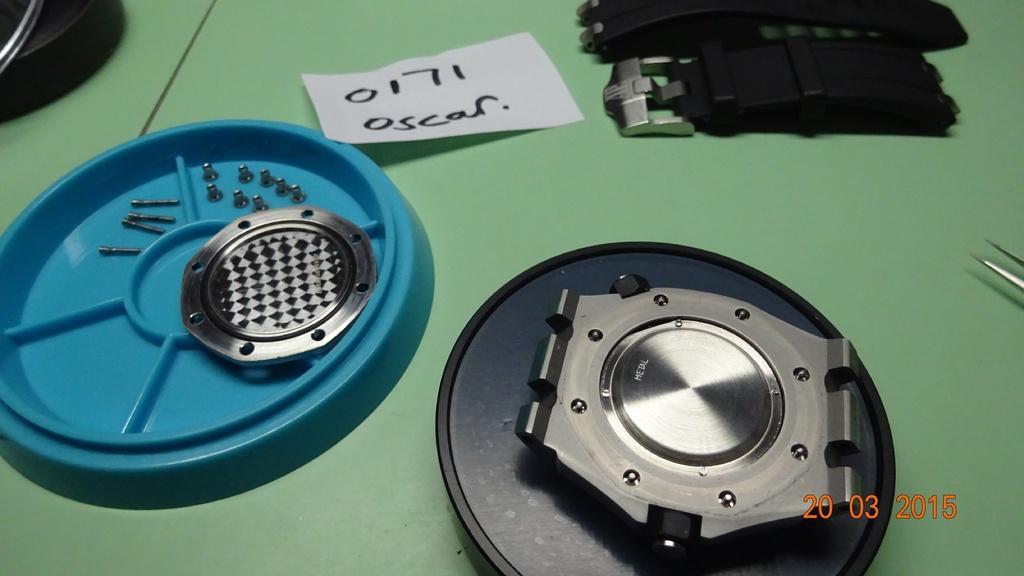How would you summarize this image in a sentence or two? There are few objects placed on a green color table. 